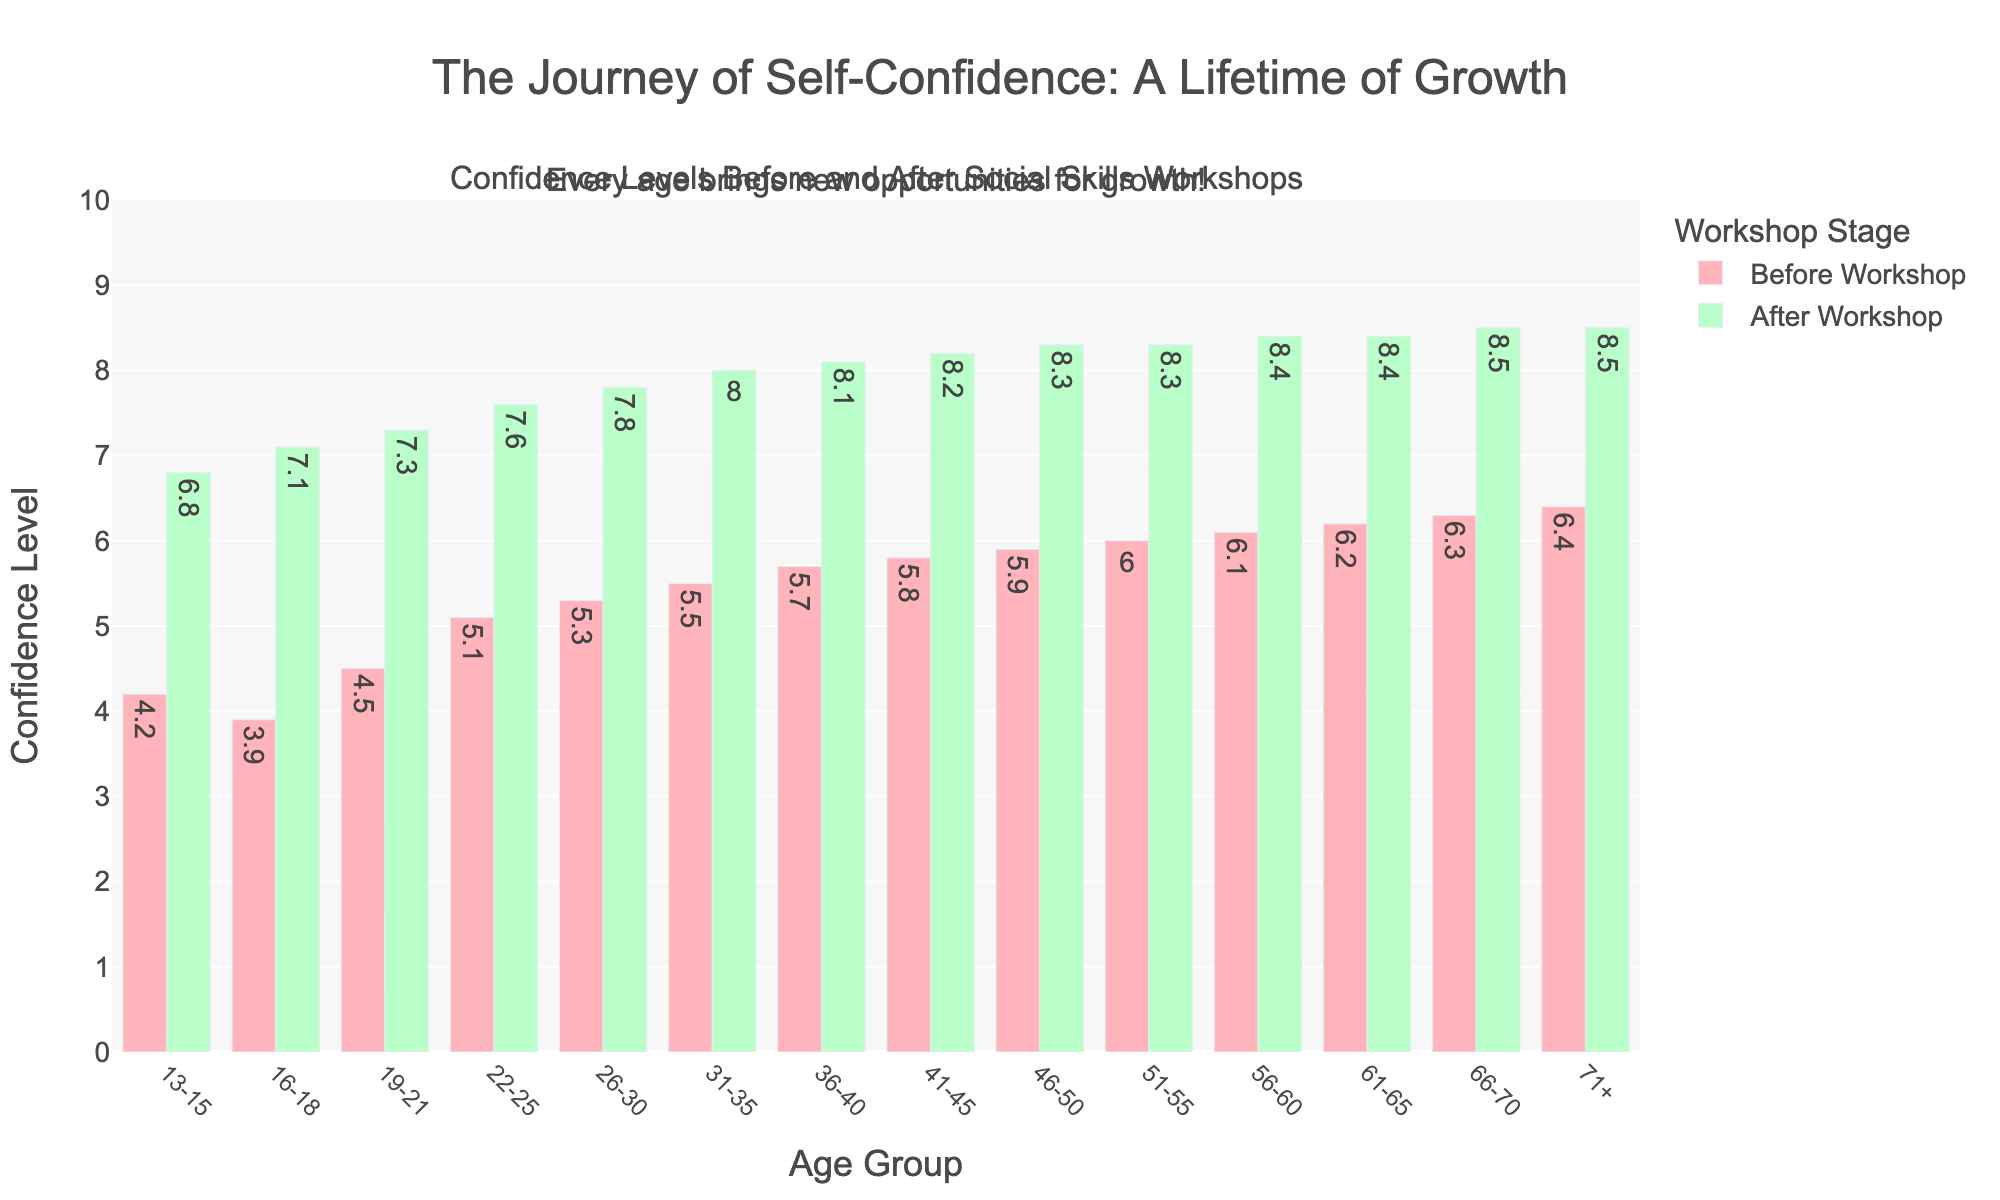what is the increase in confidence level for the age group 19-21? To determine the increase, subtract the confidence level before the workshop from the confidence level after the workshop for the age group 19-21. This is 7.3 - 4.5.
Answer: 2.8 Which age group had the highest self-reported confidence level after the workshop? To find the highest self-reported confidence level after the workshop, compare the values in the "After Workshop" column. The age group 66-70 and 71+ both have a level of 8.5, which is the highest.
Answer: 66-70 and 71+ How does the confidence increase from 13-15 compare to the increase from 41-45? First, find the increases for both age groups. For 13-15, it's 6.8 - 4.2 = 2.6. For 41-45, it's 8.2 - 5.8 = 2.4. Then, compare the 2.6 to 2.4.
Answer: The increase for 13-15 is 0.2 higher than for 41-45 what is the average confidence level before the workshop for age groups 16-18 and 22-25? To find the average, add the before values for 16-18 and 22-25, then divide by the number of groups. (3.9 + 5.1) / 2 = 4.5
Answer: 4.5 Which workshop stage is represented by the taller red bars in the chart? The taller red bars represent the confidence levels before the workshop. Red bars are taller in comparison to green bars in several age groups before the workshop.
Answer: Before the workshop Which age group experienced the smallest change in confidence levels? To find the smallest change, calculate the differences between "Before Workshop" and "After Workshop" for each age group. The smallest change is for age group 66-70: 8.5 - 6.3 = 2.2
Answer: 66-70 What is the total increase in confidence levels for the age groups from 51-55 to 61-65? Calculate the increase for each age group: 8.3 - 6.0 = 2.3, 8.4 - 6.1 = 2.3, 8.4 - 6.2 = 2.2. Add them together: 2.3 + 2.3 + 2.2 = 6.8
Answer: 6.8 Which age group had a higher confidence level before the workshop, 56-60 or 31-35? Compare the "Before Workshop" values. 6.1 for 56-60 and 5.5 for 31-35. 6.1 is higher than 5.5
Answer: 56-60 What is the difference between the highest and lowest after-workshop confidence levels? The highest after-workshop level is 8.5, and the lowest is 6.8. 8.5 - 6.8 = 1.7
Answer: 1.7 